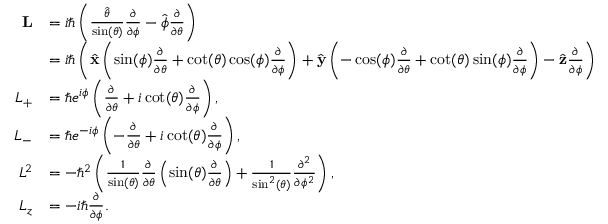<formula> <loc_0><loc_0><loc_500><loc_500>{ \begin{array} { r l } { L } & { = i \hbar { \left } ( { \frac { \hat { \theta } } { \sin ( \theta ) } } { \frac { \partial } { \partial \phi } } - { \hat { \phi } } { \frac { \partial } { \partial \theta } } \right ) } \\ & { = i \hbar { \left } ( { \hat { x } } \left ( \sin ( \phi ) { \frac { \partial } { \partial \theta } } + \cot ( \theta ) \cos ( \phi ) { \frac { \partial } { \partial \phi } } \right ) + { \hat { y } } \left ( - \cos ( \phi ) { \frac { \partial } { \partial \theta } } + \cot ( \theta ) \sin ( \phi ) { \frac { \partial } { \partial \phi } } \right ) - { \hat { z } } { \frac { \partial } { \partial \phi } } \right ) } \\ { L _ { + } } & { = \hbar { e } ^ { i \phi } \left ( { \frac { \partial } { \partial \theta } } + i \cot ( \theta ) { \frac { \partial } { \partial \phi } } \right ) , } \\ { L _ { - } } & { = \hbar { e } ^ { - i \phi } \left ( - { \frac { \partial } { \partial \theta } } + i \cot ( \theta ) { \frac { \partial } { \partial \phi } } \right ) , } \\ { L ^ { 2 } } & { = - \hbar { ^ } { 2 } \left ( { \frac { 1 } { \sin ( \theta ) } } { \frac { \partial } { \partial \theta } } \left ( \sin ( \theta ) { \frac { \partial } { \partial \theta } } \right ) + { \frac { 1 } { \sin ^ { 2 } ( \theta ) } } { \frac { \partial ^ { 2 } } { \partial \phi ^ { 2 } } } \right ) , } \\ { L _ { z } } & { = - i \hbar { \frac { \partial } { \partial \phi } } . } \end{array} }</formula> 